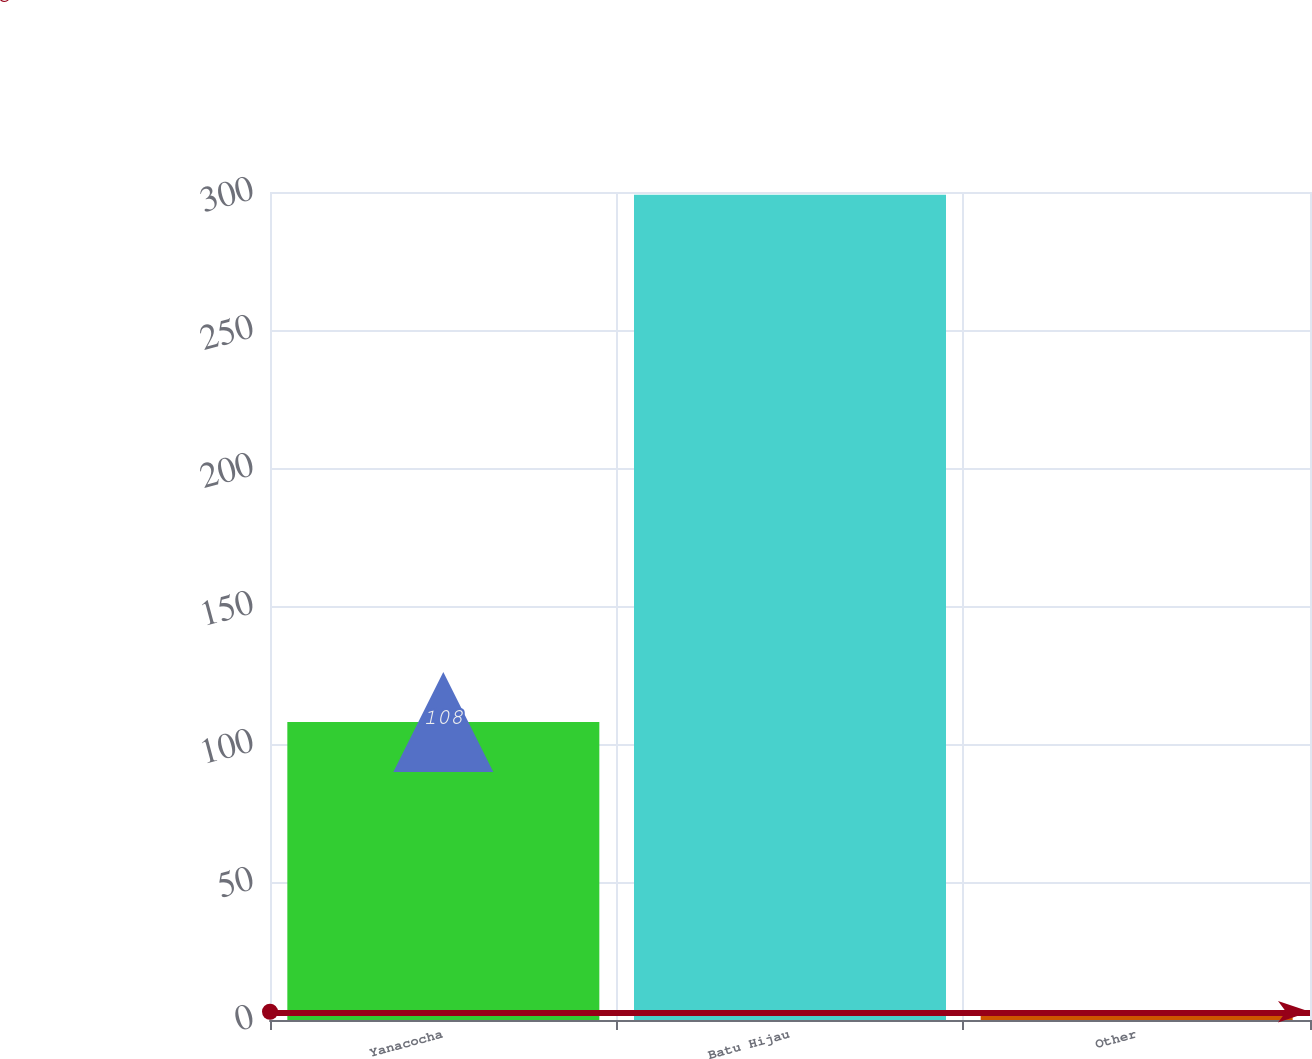Convert chart to OTSL. <chart><loc_0><loc_0><loc_500><loc_500><bar_chart><fcel>Yanacocha<fcel>Batu Hijau<fcel>Other<nl><fcel>108<fcel>299<fcel>3<nl></chart> 